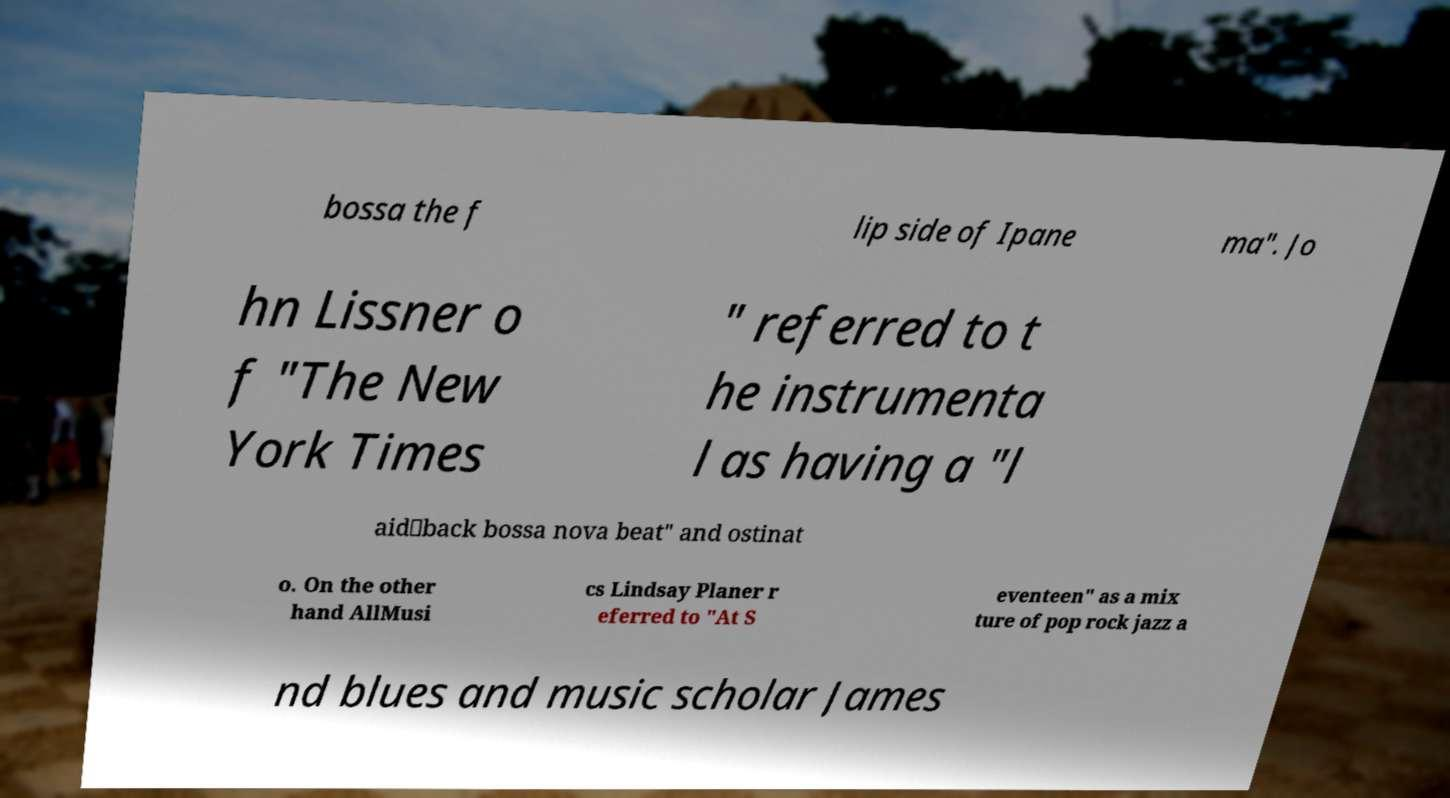What messages or text are displayed in this image? I need them in a readable, typed format. bossa the f lip side of Ipane ma". Jo hn Lissner o f "The New York Times " referred to t he instrumenta l as having a "l aid‐back bossa nova beat" and ostinat o. On the other hand AllMusi cs Lindsay Planer r eferred to "At S eventeen" as a mix ture of pop rock jazz a nd blues and music scholar James 